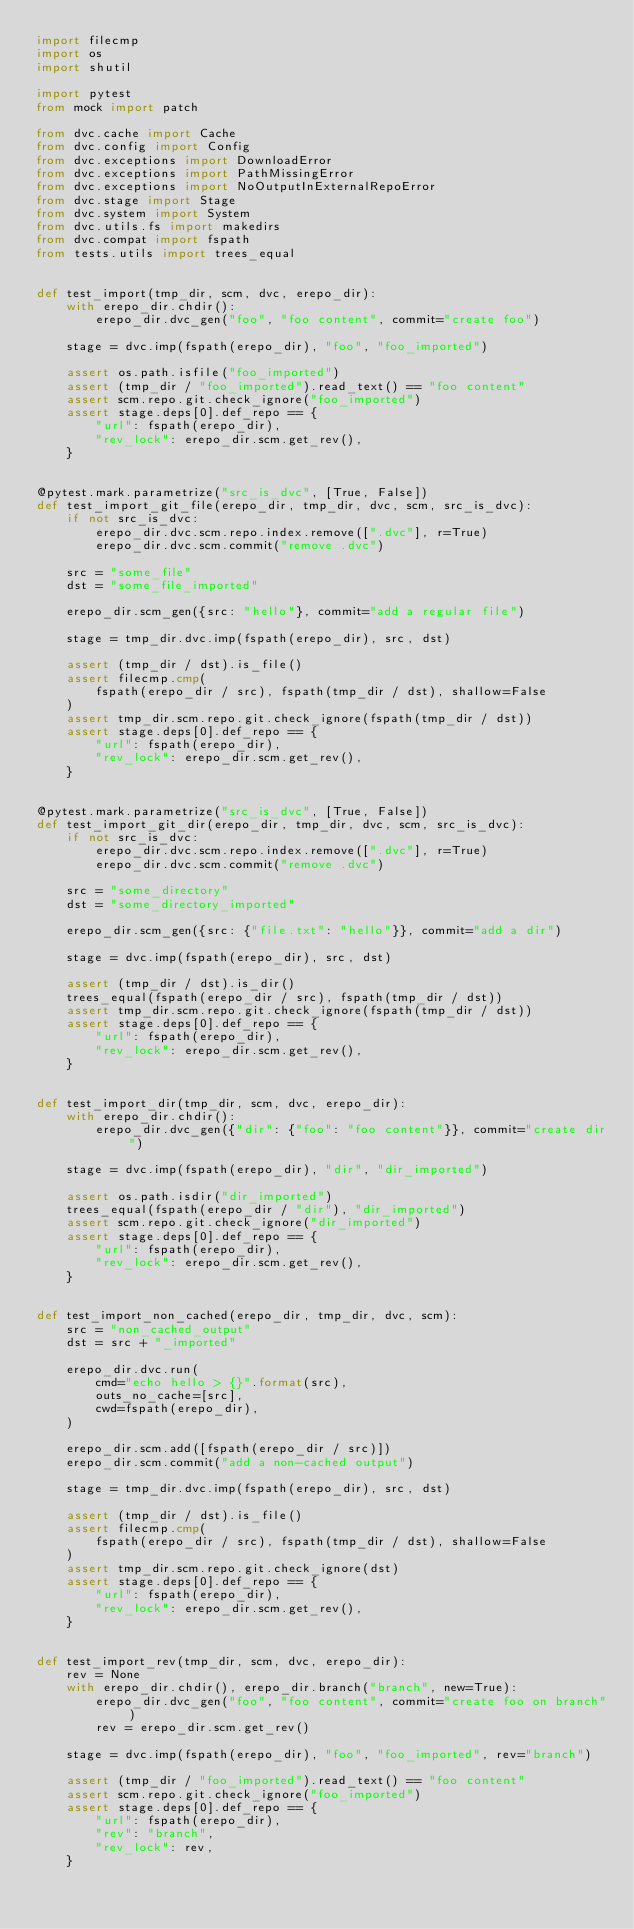<code> <loc_0><loc_0><loc_500><loc_500><_Python_>import filecmp
import os
import shutil

import pytest
from mock import patch

from dvc.cache import Cache
from dvc.config import Config
from dvc.exceptions import DownloadError
from dvc.exceptions import PathMissingError
from dvc.exceptions import NoOutputInExternalRepoError
from dvc.stage import Stage
from dvc.system import System
from dvc.utils.fs import makedirs
from dvc.compat import fspath
from tests.utils import trees_equal


def test_import(tmp_dir, scm, dvc, erepo_dir):
    with erepo_dir.chdir():
        erepo_dir.dvc_gen("foo", "foo content", commit="create foo")

    stage = dvc.imp(fspath(erepo_dir), "foo", "foo_imported")

    assert os.path.isfile("foo_imported")
    assert (tmp_dir / "foo_imported").read_text() == "foo content"
    assert scm.repo.git.check_ignore("foo_imported")
    assert stage.deps[0].def_repo == {
        "url": fspath(erepo_dir),
        "rev_lock": erepo_dir.scm.get_rev(),
    }


@pytest.mark.parametrize("src_is_dvc", [True, False])
def test_import_git_file(erepo_dir, tmp_dir, dvc, scm, src_is_dvc):
    if not src_is_dvc:
        erepo_dir.dvc.scm.repo.index.remove([".dvc"], r=True)
        erepo_dir.dvc.scm.commit("remove .dvc")

    src = "some_file"
    dst = "some_file_imported"

    erepo_dir.scm_gen({src: "hello"}, commit="add a regular file")

    stage = tmp_dir.dvc.imp(fspath(erepo_dir), src, dst)

    assert (tmp_dir / dst).is_file()
    assert filecmp.cmp(
        fspath(erepo_dir / src), fspath(tmp_dir / dst), shallow=False
    )
    assert tmp_dir.scm.repo.git.check_ignore(fspath(tmp_dir / dst))
    assert stage.deps[0].def_repo == {
        "url": fspath(erepo_dir),
        "rev_lock": erepo_dir.scm.get_rev(),
    }


@pytest.mark.parametrize("src_is_dvc", [True, False])
def test_import_git_dir(erepo_dir, tmp_dir, dvc, scm, src_is_dvc):
    if not src_is_dvc:
        erepo_dir.dvc.scm.repo.index.remove([".dvc"], r=True)
        erepo_dir.dvc.scm.commit("remove .dvc")

    src = "some_directory"
    dst = "some_directory_imported"

    erepo_dir.scm_gen({src: {"file.txt": "hello"}}, commit="add a dir")

    stage = dvc.imp(fspath(erepo_dir), src, dst)

    assert (tmp_dir / dst).is_dir()
    trees_equal(fspath(erepo_dir / src), fspath(tmp_dir / dst))
    assert tmp_dir.scm.repo.git.check_ignore(fspath(tmp_dir / dst))
    assert stage.deps[0].def_repo == {
        "url": fspath(erepo_dir),
        "rev_lock": erepo_dir.scm.get_rev(),
    }


def test_import_dir(tmp_dir, scm, dvc, erepo_dir):
    with erepo_dir.chdir():
        erepo_dir.dvc_gen({"dir": {"foo": "foo content"}}, commit="create dir")

    stage = dvc.imp(fspath(erepo_dir), "dir", "dir_imported")

    assert os.path.isdir("dir_imported")
    trees_equal(fspath(erepo_dir / "dir"), "dir_imported")
    assert scm.repo.git.check_ignore("dir_imported")
    assert stage.deps[0].def_repo == {
        "url": fspath(erepo_dir),
        "rev_lock": erepo_dir.scm.get_rev(),
    }


def test_import_non_cached(erepo_dir, tmp_dir, dvc, scm):
    src = "non_cached_output"
    dst = src + "_imported"

    erepo_dir.dvc.run(
        cmd="echo hello > {}".format(src),
        outs_no_cache=[src],
        cwd=fspath(erepo_dir),
    )

    erepo_dir.scm.add([fspath(erepo_dir / src)])
    erepo_dir.scm.commit("add a non-cached output")

    stage = tmp_dir.dvc.imp(fspath(erepo_dir), src, dst)

    assert (tmp_dir / dst).is_file()
    assert filecmp.cmp(
        fspath(erepo_dir / src), fspath(tmp_dir / dst), shallow=False
    )
    assert tmp_dir.scm.repo.git.check_ignore(dst)
    assert stage.deps[0].def_repo == {
        "url": fspath(erepo_dir),
        "rev_lock": erepo_dir.scm.get_rev(),
    }


def test_import_rev(tmp_dir, scm, dvc, erepo_dir):
    rev = None
    with erepo_dir.chdir(), erepo_dir.branch("branch", new=True):
        erepo_dir.dvc_gen("foo", "foo content", commit="create foo on branch")
        rev = erepo_dir.scm.get_rev()

    stage = dvc.imp(fspath(erepo_dir), "foo", "foo_imported", rev="branch")

    assert (tmp_dir / "foo_imported").read_text() == "foo content"
    assert scm.repo.git.check_ignore("foo_imported")
    assert stage.deps[0].def_repo == {
        "url": fspath(erepo_dir),
        "rev": "branch",
        "rev_lock": rev,
    }

</code> 